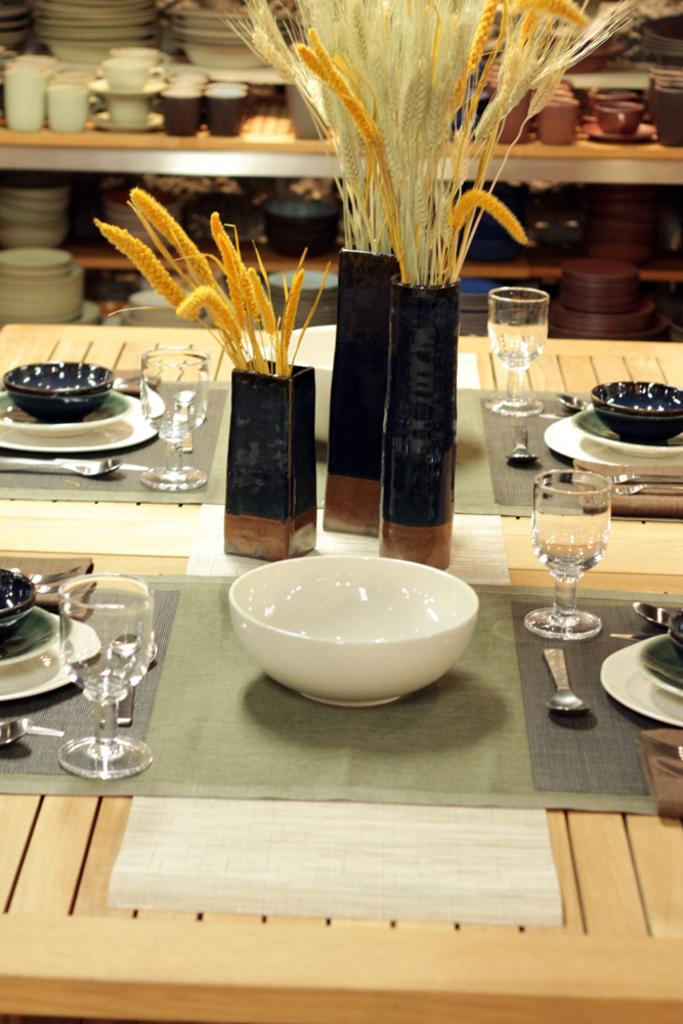What is the person in the image doing? The person is riding a bicycle. What can be seen in the background of the image? There is a road and trees in the background. What type of sound can be heard coming from the ship in the image? There is no ship present in the image, so it is not possible to determine what, if any, sound might be heard. 